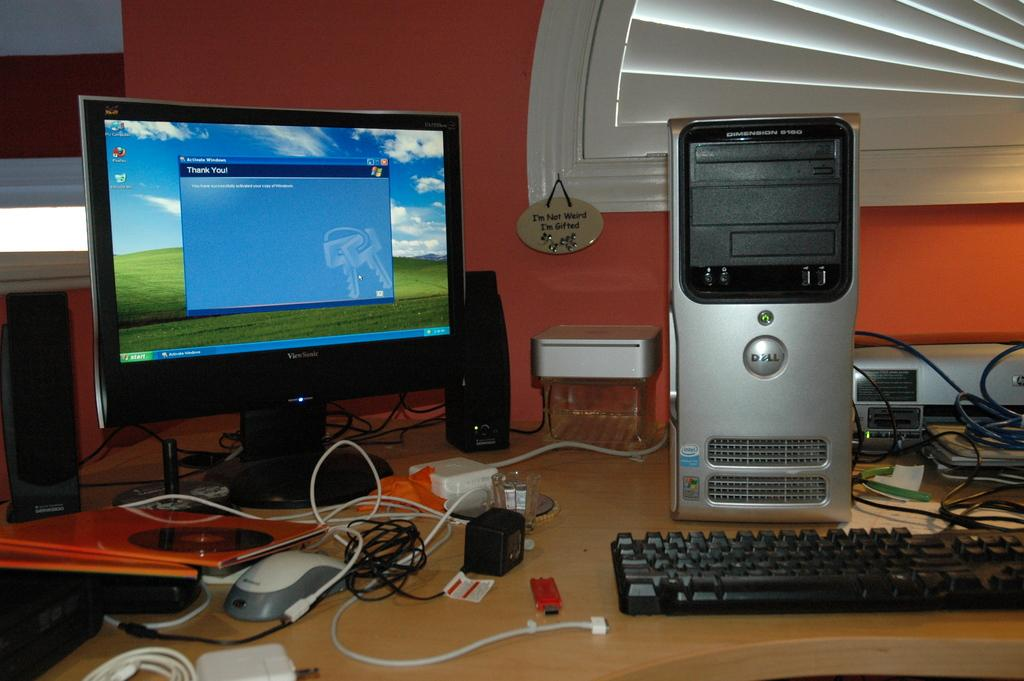<image>
Provide a brief description of the given image. A message on the display says "thank you!" 